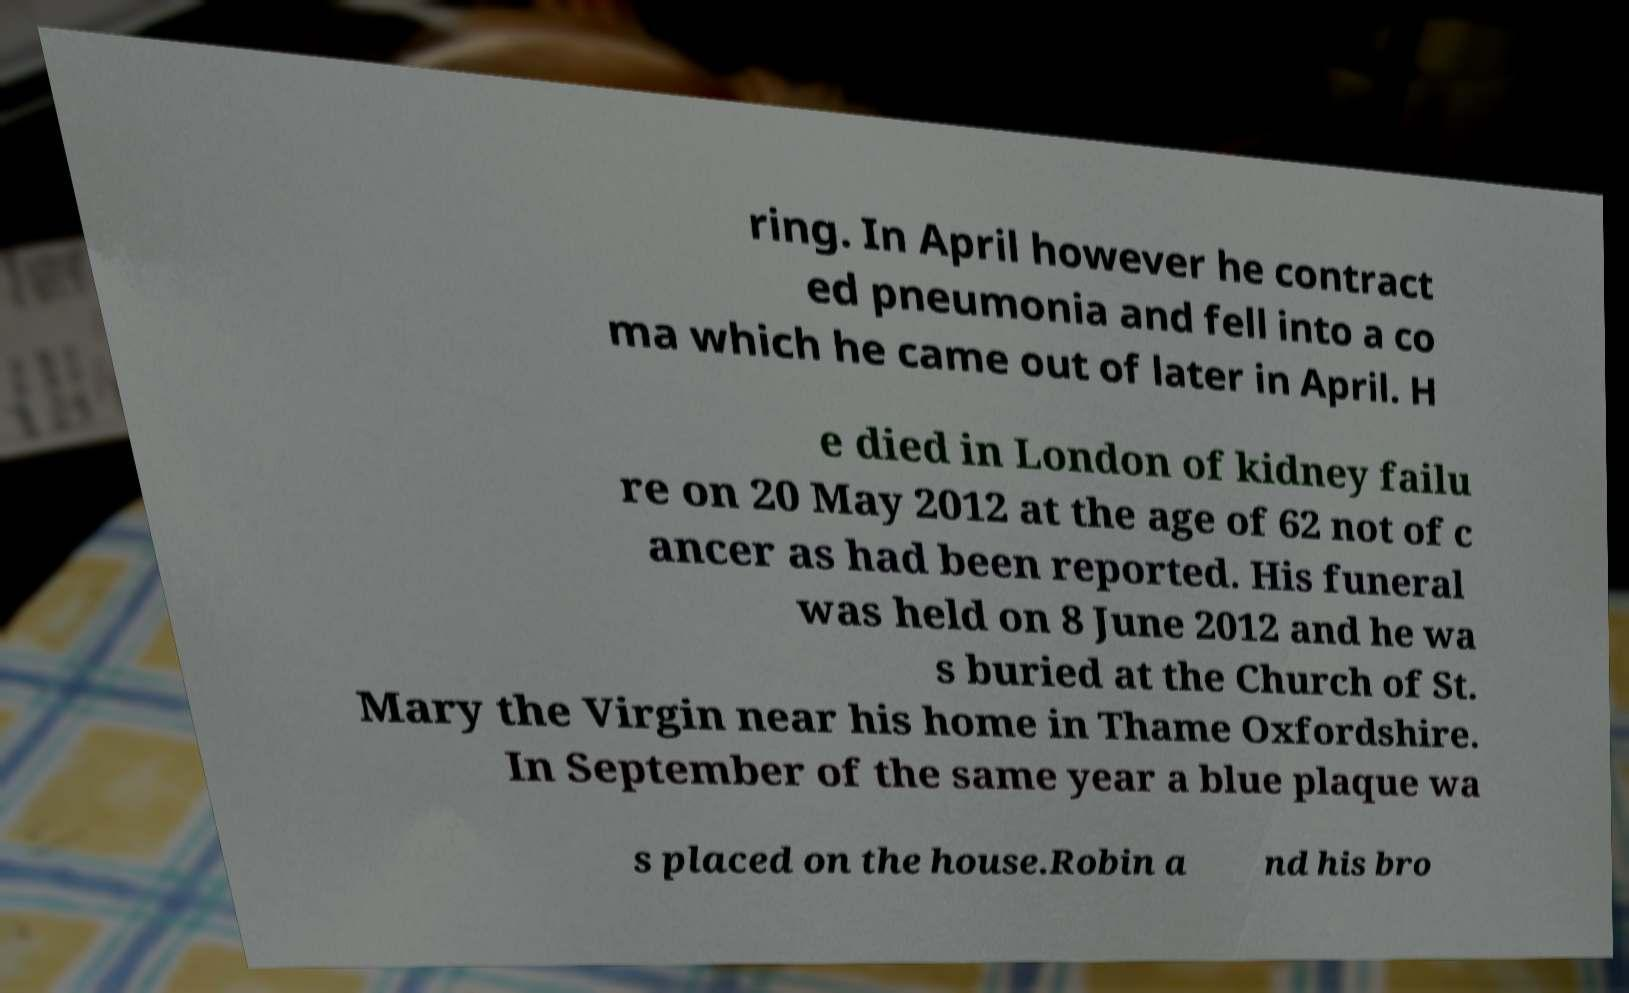Please identify and transcribe the text found in this image. ring. In April however he contract ed pneumonia and fell into a co ma which he came out of later in April. H e died in London of kidney failu re on 20 May 2012 at the age of 62 not of c ancer as had been reported. His funeral was held on 8 June 2012 and he wa s buried at the Church of St. Mary the Virgin near his home in Thame Oxfordshire. In September of the same year a blue plaque wa s placed on the house.Robin a nd his bro 